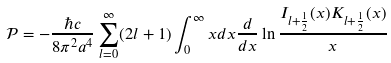<formula> <loc_0><loc_0><loc_500><loc_500>\mathcal { P } = - \frac { \hbar { c } } { 8 \pi ^ { 2 } a ^ { 4 } } \sum _ { l = 0 } ^ { \infty } ( 2 l + 1 ) \int _ { 0 } ^ { \infty } x d x \frac { d } { d x } \ln \frac { I _ { l + \frac { 1 } { 2 } } ( x ) K _ { l + \frac { 1 } { 2 } } ( x ) } { x }</formula> 